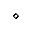<formula> <loc_0><loc_0><loc_500><loc_500>\diamond</formula> 